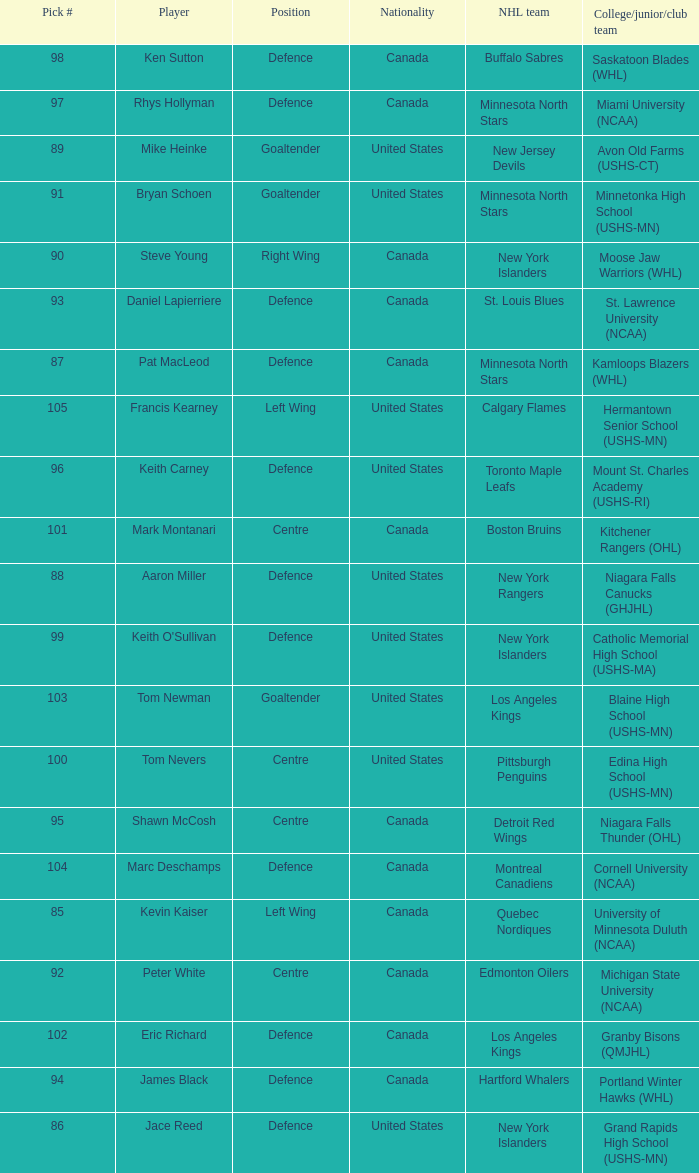What position did the #94 pick play? Defence. 